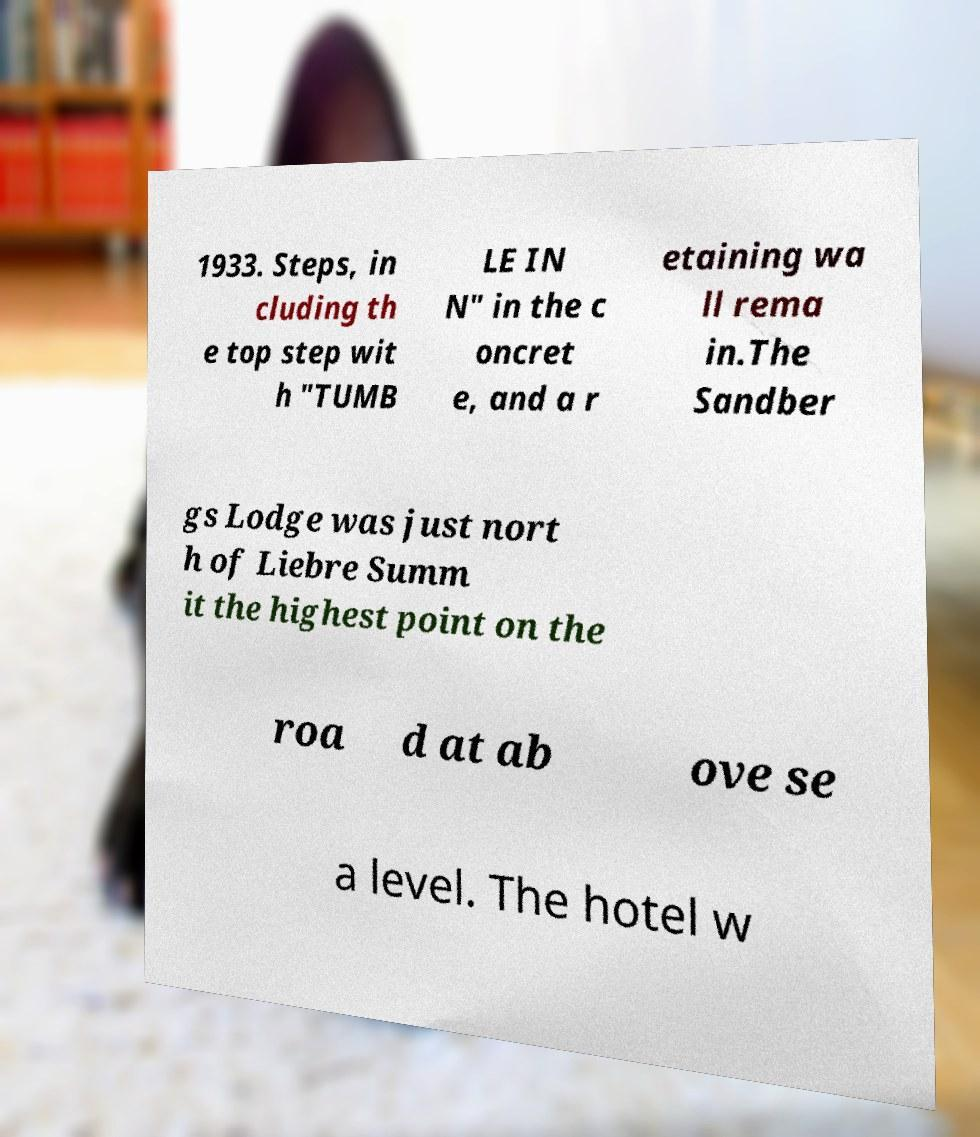What messages or text are displayed in this image? I need them in a readable, typed format. 1933. Steps, in cluding th e top step wit h "TUMB LE IN N" in the c oncret e, and a r etaining wa ll rema in.The Sandber gs Lodge was just nort h of Liebre Summ it the highest point on the roa d at ab ove se a level. The hotel w 